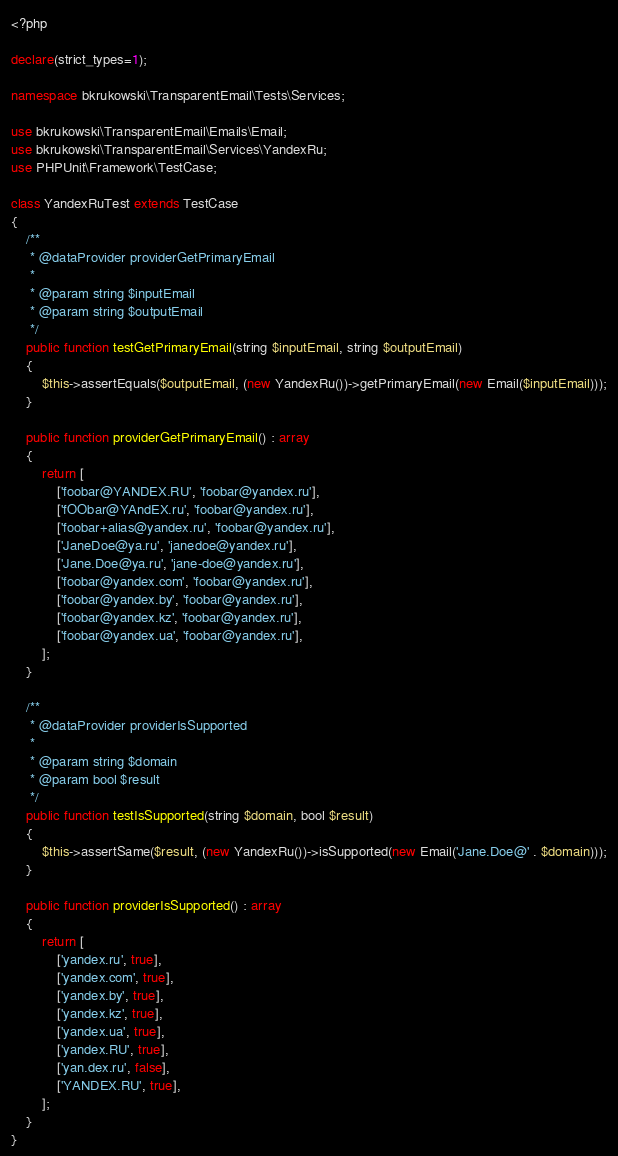<code> <loc_0><loc_0><loc_500><loc_500><_PHP_><?php

declare(strict_types=1);

namespace bkrukowski\TransparentEmail\Tests\Services;

use bkrukowski\TransparentEmail\Emails\Email;
use bkrukowski\TransparentEmail\Services\YandexRu;
use PHPUnit\Framework\TestCase;

class YandexRuTest extends TestCase
{
    /**
     * @dataProvider providerGetPrimaryEmail
     *
     * @param string $inputEmail
     * @param string $outputEmail
     */
    public function testGetPrimaryEmail(string $inputEmail, string $outputEmail)
    {
        $this->assertEquals($outputEmail, (new YandexRu())->getPrimaryEmail(new Email($inputEmail)));
    }

    public function providerGetPrimaryEmail() : array
    {
        return [
            ['foobar@YANDEX.RU', 'foobar@yandex.ru'],
            ['fOObar@YAndEX.ru', 'foobar@yandex.ru'],
            ['foobar+alias@yandex.ru', 'foobar@yandex.ru'],
            ['JaneDoe@ya.ru', 'janedoe@yandex.ru'],
            ['Jane.Doe@ya.ru', 'jane-doe@yandex.ru'],
            ['foobar@yandex.com', 'foobar@yandex.ru'],
            ['foobar@yandex.by', 'foobar@yandex.ru'],
            ['foobar@yandex.kz', 'foobar@yandex.ru'],
            ['foobar@yandex.ua', 'foobar@yandex.ru'],
        ];
    }

    /**
     * @dataProvider providerIsSupported
     *
     * @param string $domain
     * @param bool $result
     */
    public function testIsSupported(string $domain, bool $result)
    {
        $this->assertSame($result, (new YandexRu())->isSupported(new Email('Jane.Doe@' . $domain)));
    }

    public function providerIsSupported() : array
    {
        return [
            ['yandex.ru', true],
            ['yandex.com', true],
            ['yandex.by', true],
            ['yandex.kz', true],
            ['yandex.ua', true],
            ['yandex.RU', true],
            ['yan.dex.ru', false],
            ['YANDEX.RU', true],
        ];
    }
}</code> 